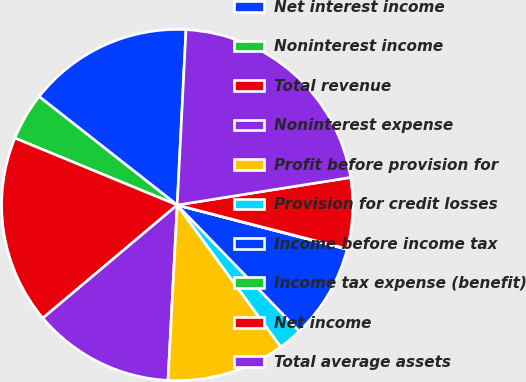Convert chart. <chart><loc_0><loc_0><loc_500><loc_500><pie_chart><fcel>Net interest income<fcel>Noninterest income<fcel>Total revenue<fcel>Noninterest expense<fcel>Profit before provision for<fcel>Provision for credit losses<fcel>Income before income tax<fcel>Income tax expense (benefit)<fcel>Net income<fcel>Total average assets<nl><fcel>15.2%<fcel>4.37%<fcel>17.36%<fcel>13.03%<fcel>10.87%<fcel>2.2%<fcel>8.7%<fcel>0.04%<fcel>6.53%<fcel>21.69%<nl></chart> 